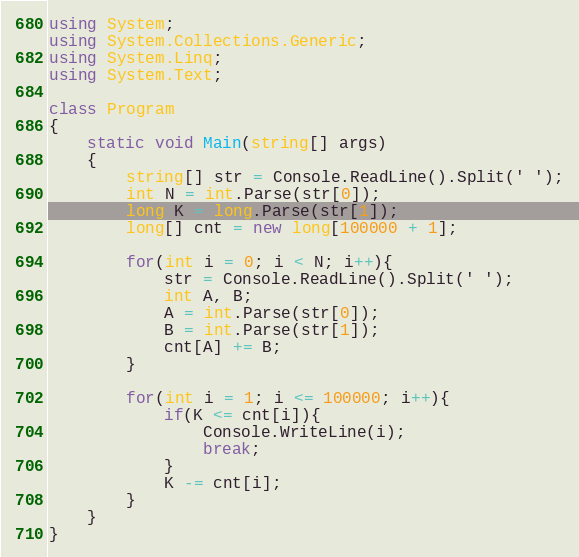<code> <loc_0><loc_0><loc_500><loc_500><_C#_>using System;
using System.Collections.Generic;
using System.Linq;
using System.Text;

class Program
{
    static void Main(string[] args)
    {
        string[] str = Console.ReadLine().Split(' ');
        int N = int.Parse(str[0]);
        long K = long.Parse(str[1]);
        long[] cnt = new long[100000 + 1];

        for(int i = 0; i < N; i++){
            str = Console.ReadLine().Split(' ');
            int A, B;
            A = int.Parse(str[0]);
            B = int.Parse(str[1]);
            cnt[A] += B;
        }

        for(int i = 1; i <= 100000; i++){
            if(K <= cnt[i]){
                Console.WriteLine(i);
                break;
            }
            K -= cnt[i];
        }
    }
}</code> 